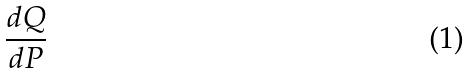Convert formula to latex. <formula><loc_0><loc_0><loc_500><loc_500>\frac { d Q } { d P }</formula> 